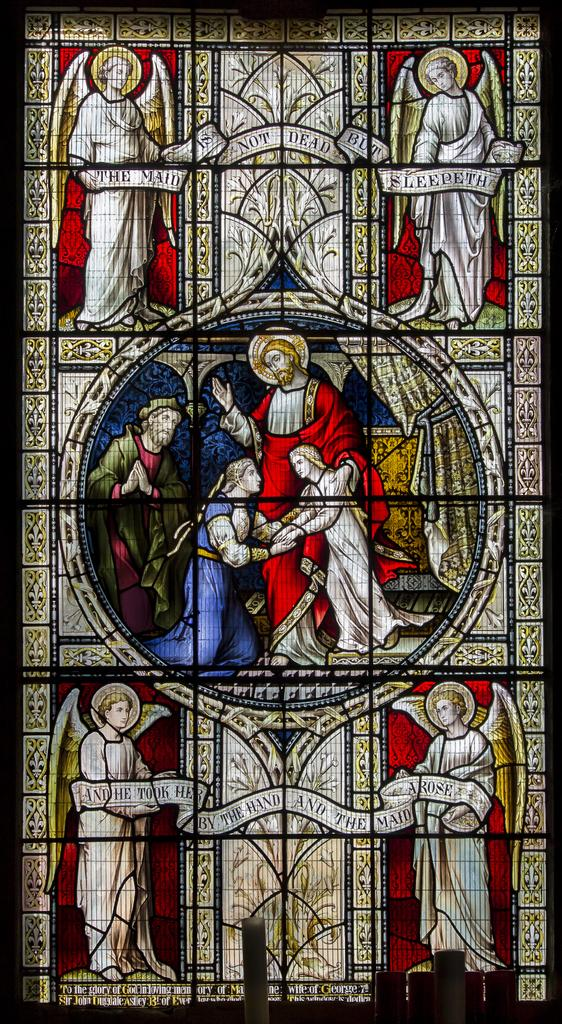What is depicted on the glass in the image? There is a painting on the glass in the image. How many cars can be seen in the painting on the glass? There is no mention of cars in the image or the provided fact. The image only states that there is a painting on the glass, without specifying its content. 